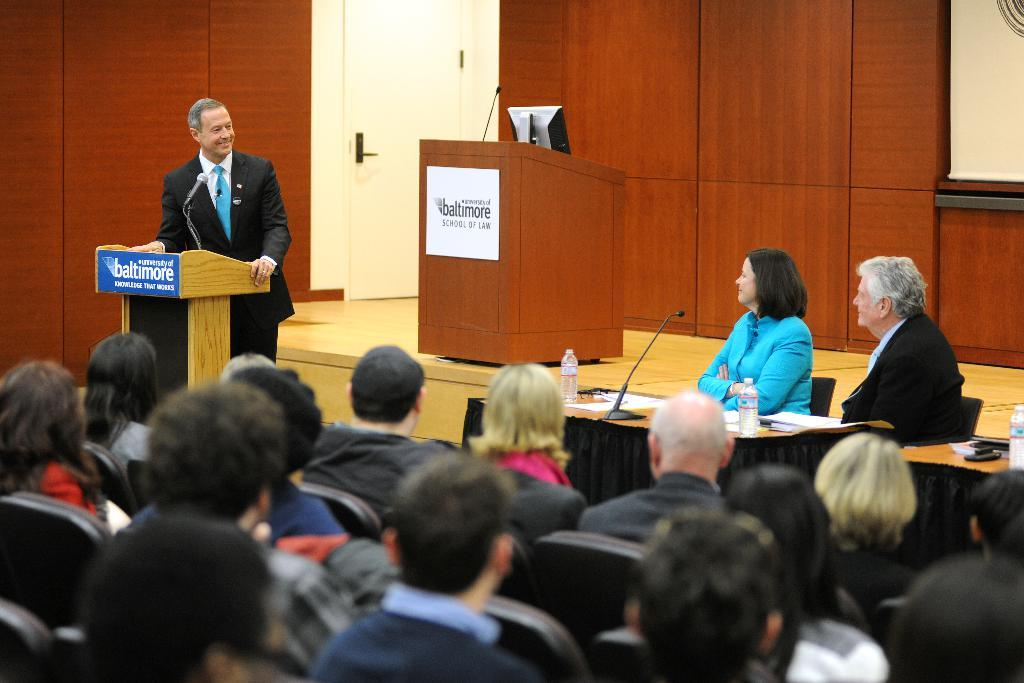How many people are in the image? There is a group of people in the image. What are the people in the image doing? The people are sitting and listening to a person. Who is addressing the group of people? A man is addressing the group of people. What is on the stage in the image? There is a podium on the stage. What type of throne is the man sitting on while addressing the group? There is no throne present in the image; the man is standing behind a podium. Can you tell me how many bananas are being held by the people in the image? There are no bananas visible in the image. 